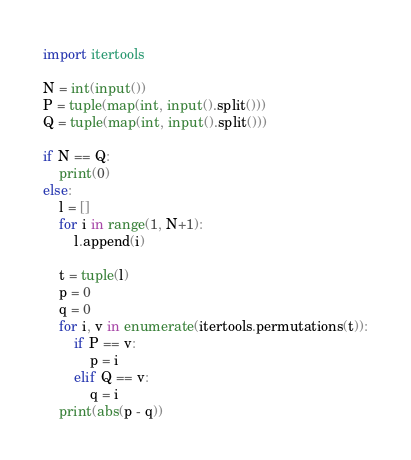<code> <loc_0><loc_0><loc_500><loc_500><_Python_>import itertools

N = int(input())
P = tuple(map(int, input().split()))
Q = tuple(map(int, input().split()))

if N == Q:
    print(0)
else:
    l = []
    for i in range(1, N+1):
        l.append(i)

    t = tuple(l)
    p = 0
    q = 0
    for i, v in enumerate(itertools.permutations(t)):
        if P == v:
            p = i
        elif Q == v:
            q = i
    print(abs(p - q))</code> 